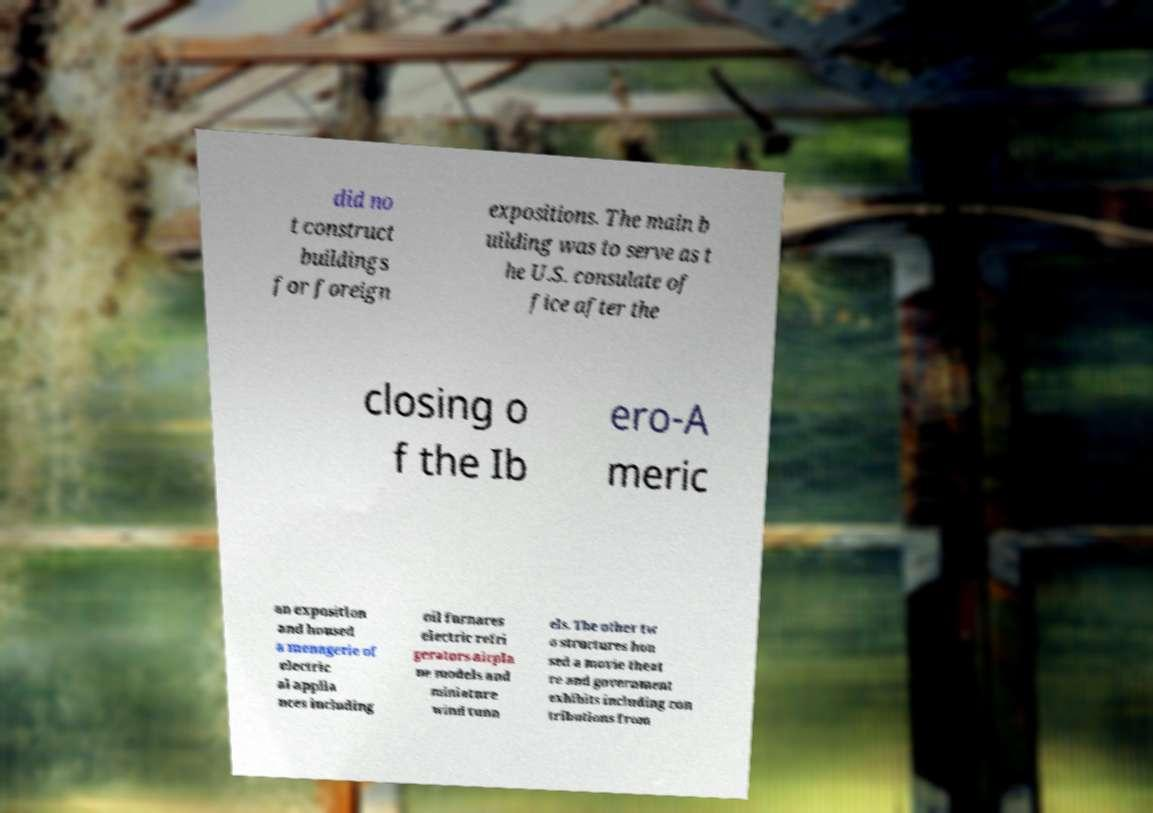Can you read and provide the text displayed in the image?This photo seems to have some interesting text. Can you extract and type it out for me? did no t construct buildings for foreign expositions. The main b uilding was to serve as t he U.S. consulate of fice after the closing o f the Ib ero-A meric an exposition and housed a menagerie of electric al applia nces including oil furnaces electric refri gerators airpla ne models and miniature wind tunn els. The other tw o structures hou sed a movie theat re and government exhibits including con tributions from 